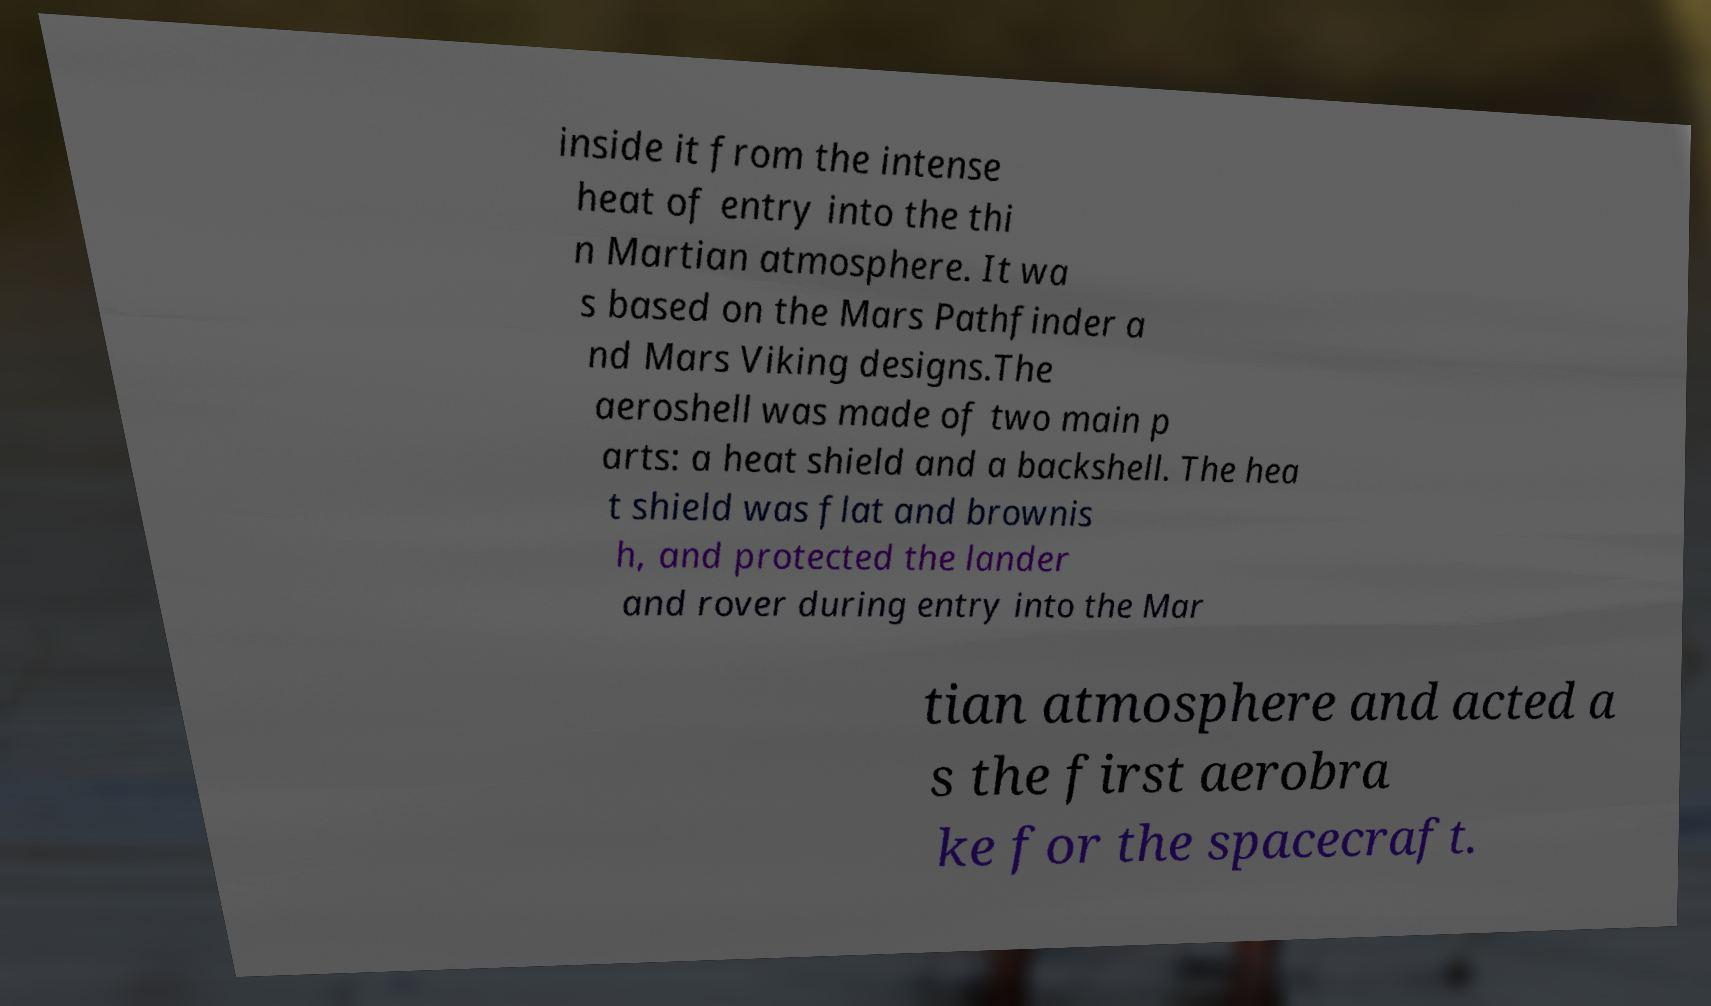For documentation purposes, I need the text within this image transcribed. Could you provide that? inside it from the intense heat of entry into the thi n Martian atmosphere. It wa s based on the Mars Pathfinder a nd Mars Viking designs.The aeroshell was made of two main p arts: a heat shield and a backshell. The hea t shield was flat and brownis h, and protected the lander and rover during entry into the Mar tian atmosphere and acted a s the first aerobra ke for the spacecraft. 